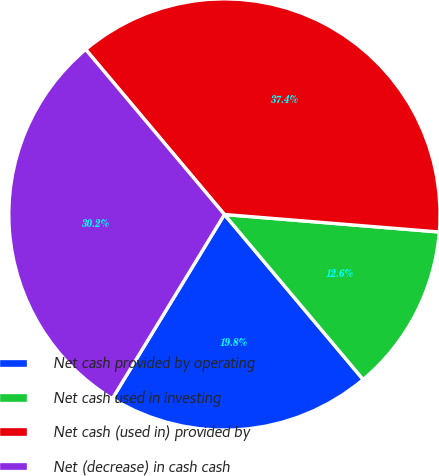Convert chart to OTSL. <chart><loc_0><loc_0><loc_500><loc_500><pie_chart><fcel>Net cash provided by operating<fcel>Net cash used in investing<fcel>Net cash (used in) provided by<fcel>Net (decrease) in cash cash<nl><fcel>19.83%<fcel>12.58%<fcel>37.42%<fcel>30.17%<nl></chart> 